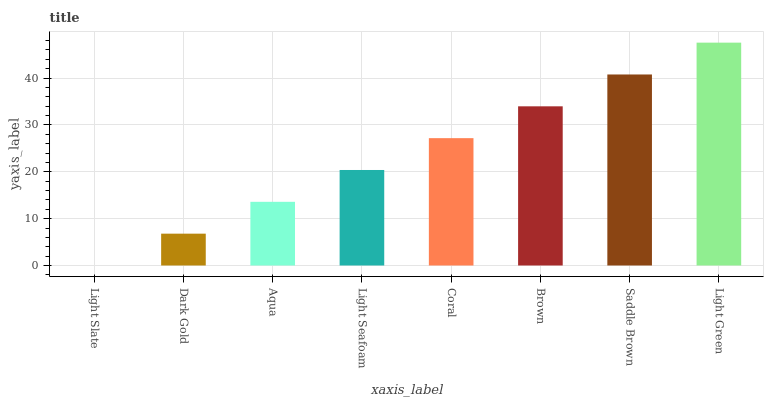Is Dark Gold the minimum?
Answer yes or no. No. Is Dark Gold the maximum?
Answer yes or no. No. Is Dark Gold greater than Light Slate?
Answer yes or no. Yes. Is Light Slate less than Dark Gold?
Answer yes or no. Yes. Is Light Slate greater than Dark Gold?
Answer yes or no. No. Is Dark Gold less than Light Slate?
Answer yes or no. No. Is Coral the high median?
Answer yes or no. Yes. Is Light Seafoam the low median?
Answer yes or no. Yes. Is Dark Gold the high median?
Answer yes or no. No. Is Dark Gold the low median?
Answer yes or no. No. 